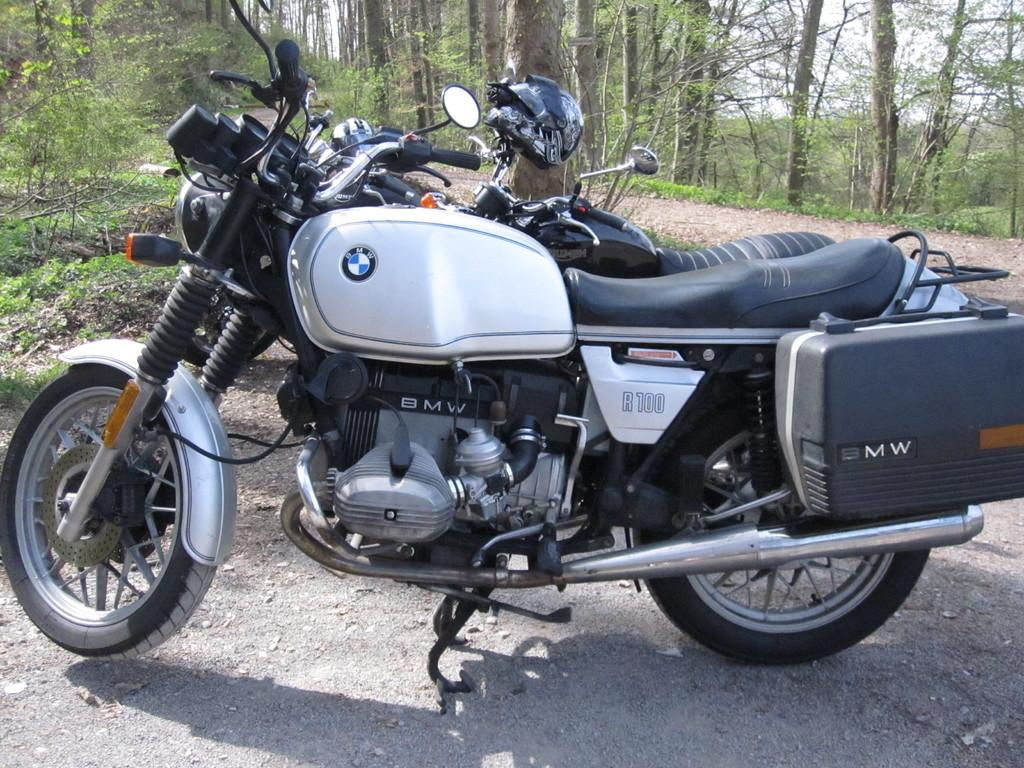What objects are parked on the road in the image? There are two bikes parked on the road in the image. What type of surface is visible in the background? There is a road in the background of the image. What can be seen on both sides of the road? There are trees and plants on both sides of the road. What is visible above the road and trees? The sky is visible in the image. How many bowls of soup can be seen on the bikes in the image? There are no bowls of soup present in the image; it features two bikes parked on the road. Are there any deer visible in the image? There are no deer present in the image; it features two bikes parked on the road, a road in the background, trees and plants on both sides of the road, and the sky visible above. 